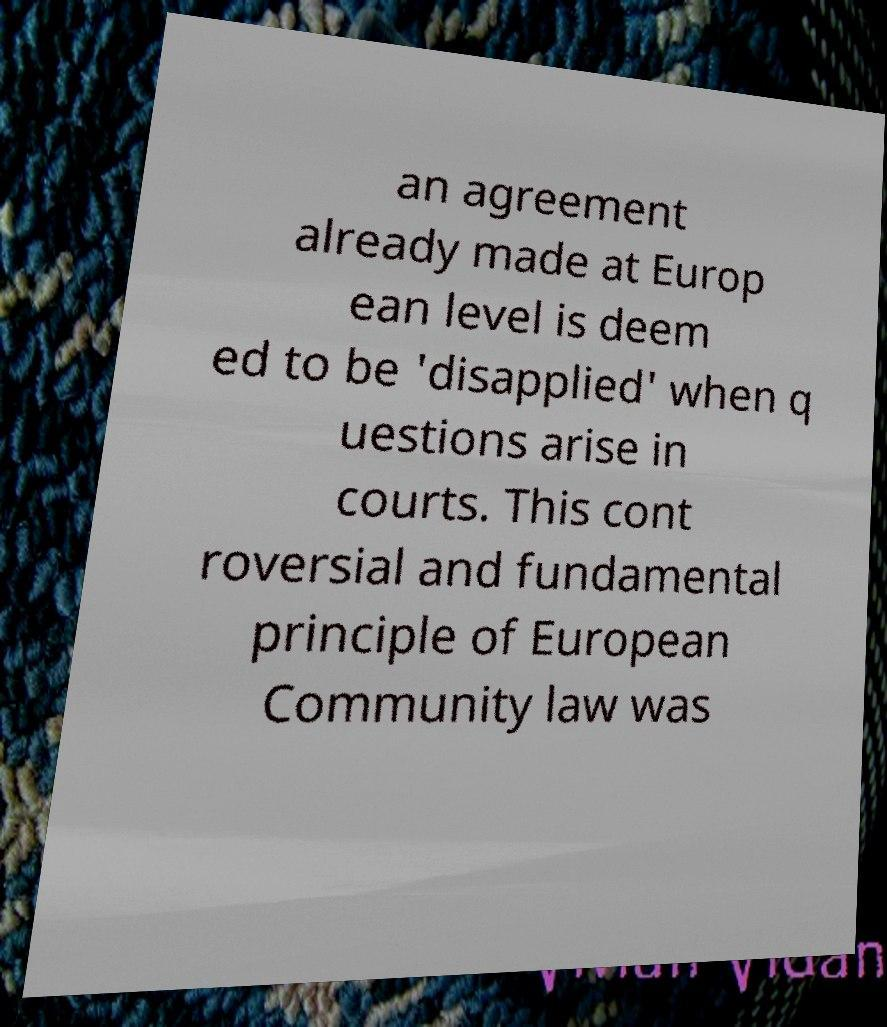Can you read and provide the text displayed in the image?This photo seems to have some interesting text. Can you extract and type it out for me? an agreement already made at Europ ean level is deem ed to be 'disapplied' when q uestions arise in courts. This cont roversial and fundamental principle of European Community law was 